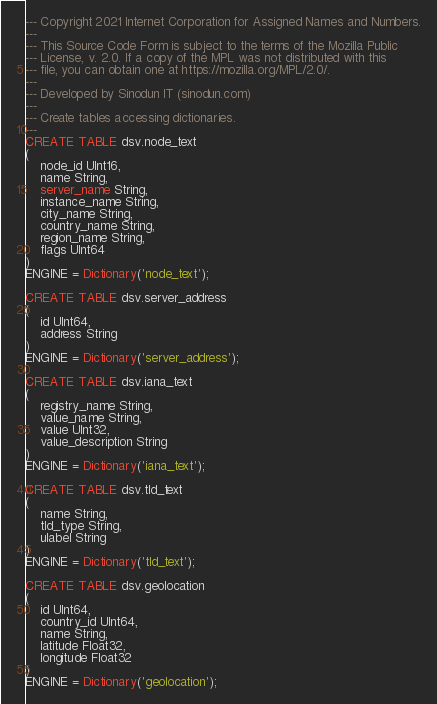Convert code to text. <code><loc_0><loc_0><loc_500><loc_500><_SQL_>--- Copyright 2021 Internet Corporation for Assigned Names and Numbers.
---
--- This Source Code Form is subject to the terms of the Mozilla Public
--- License, v. 2.0. If a copy of the MPL was not distributed with this
--- file, you can obtain one at https://mozilla.org/MPL/2.0/.
---
--- Developed by Sinodun IT (sinodun.com)
---
--- Create tables accessing dictionaries.
---
CREATE TABLE dsv.node_text
(
    node_id UInt16,
    name String,
    server_name String,
    instance_name String,
    city_name String,
    country_name String,
    region_name String,
    flags UInt64
)
ENGINE = Dictionary('node_text');

CREATE TABLE dsv.server_address
(
    id UInt64,
    address String
)
ENGINE = Dictionary('server_address');

CREATE TABLE dsv.iana_text
(
    registry_name String,
    value_name String,
    value UInt32,
    value_description String
)
ENGINE = Dictionary('iana_text');

CREATE TABLE dsv.tld_text
(
    name String,
    tld_type String,
    ulabel String
)
ENGINE = Dictionary('tld_text');

CREATE TABLE dsv.geolocation
(
    id UInt64,
    country_id UInt64,
    name String,
    latitude Float32,
    longitude Float32
)
ENGINE = Dictionary('geolocation');
</code> 